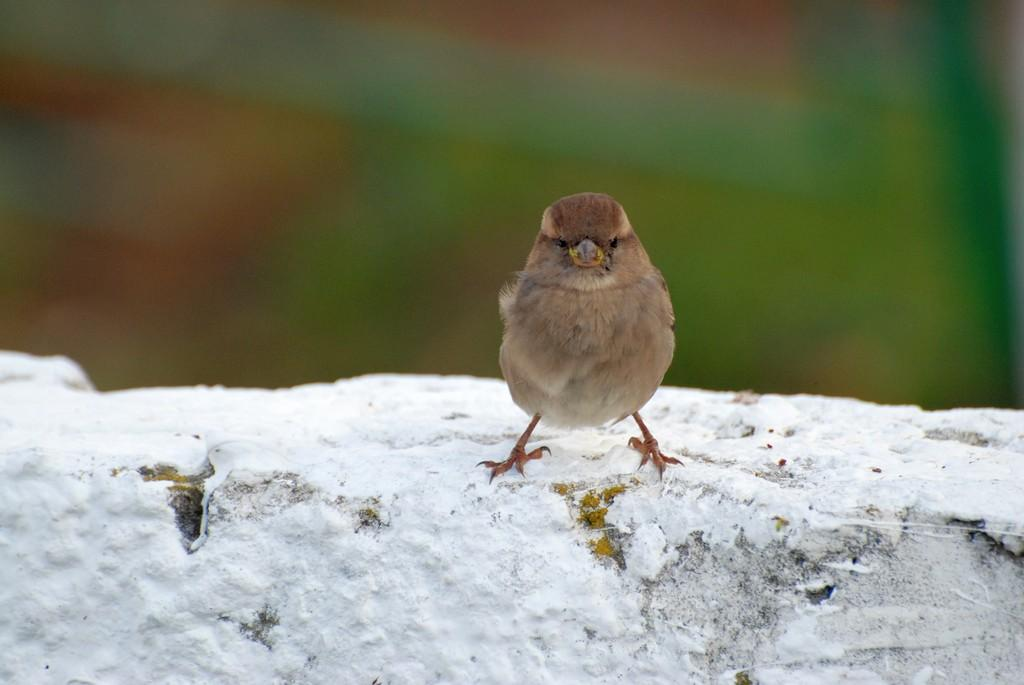What type of animal can be seen in the image? There is a bird in the image. What color is the bird? The bird is brown in color. Where is the bird located in the image? The bird is on the wall. What is covering the wall in the image? There is snow on the wall. How would you describe the background of the image? The background of the image is blurred. How many frogs are sitting on the bird's head in the image? There are no frogs present in the image, so it is not possible to determine how many might be sitting on the bird's head. 